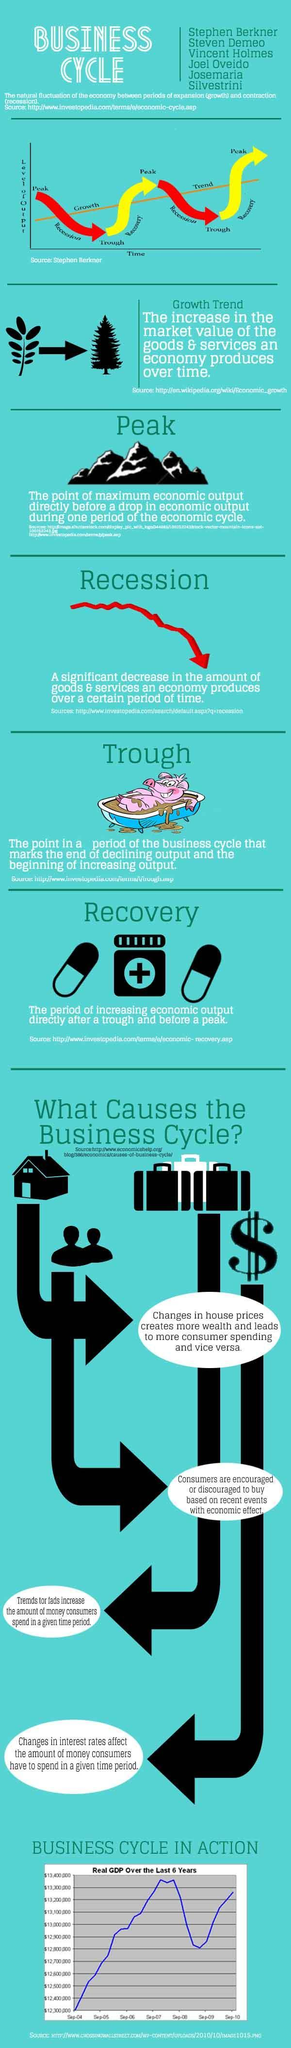How many tablets are under the heading recovery?
Answer the question with a short phrase. 2 Which color is used to represent recovery in the graph-red, yellow, or black? yellow Which color is used to represent recession in the graph-red, yellow, or black? red 